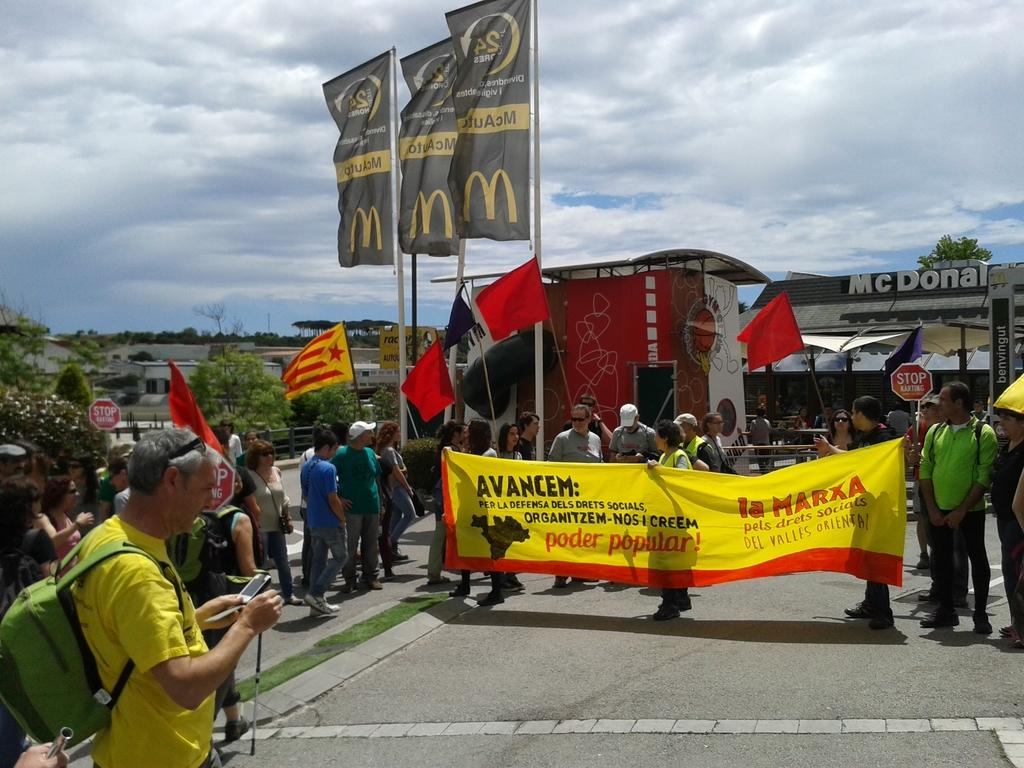<image>
Provide a brief description of the given image. Several people hold a sign in front of a McDonald's restaurant. 